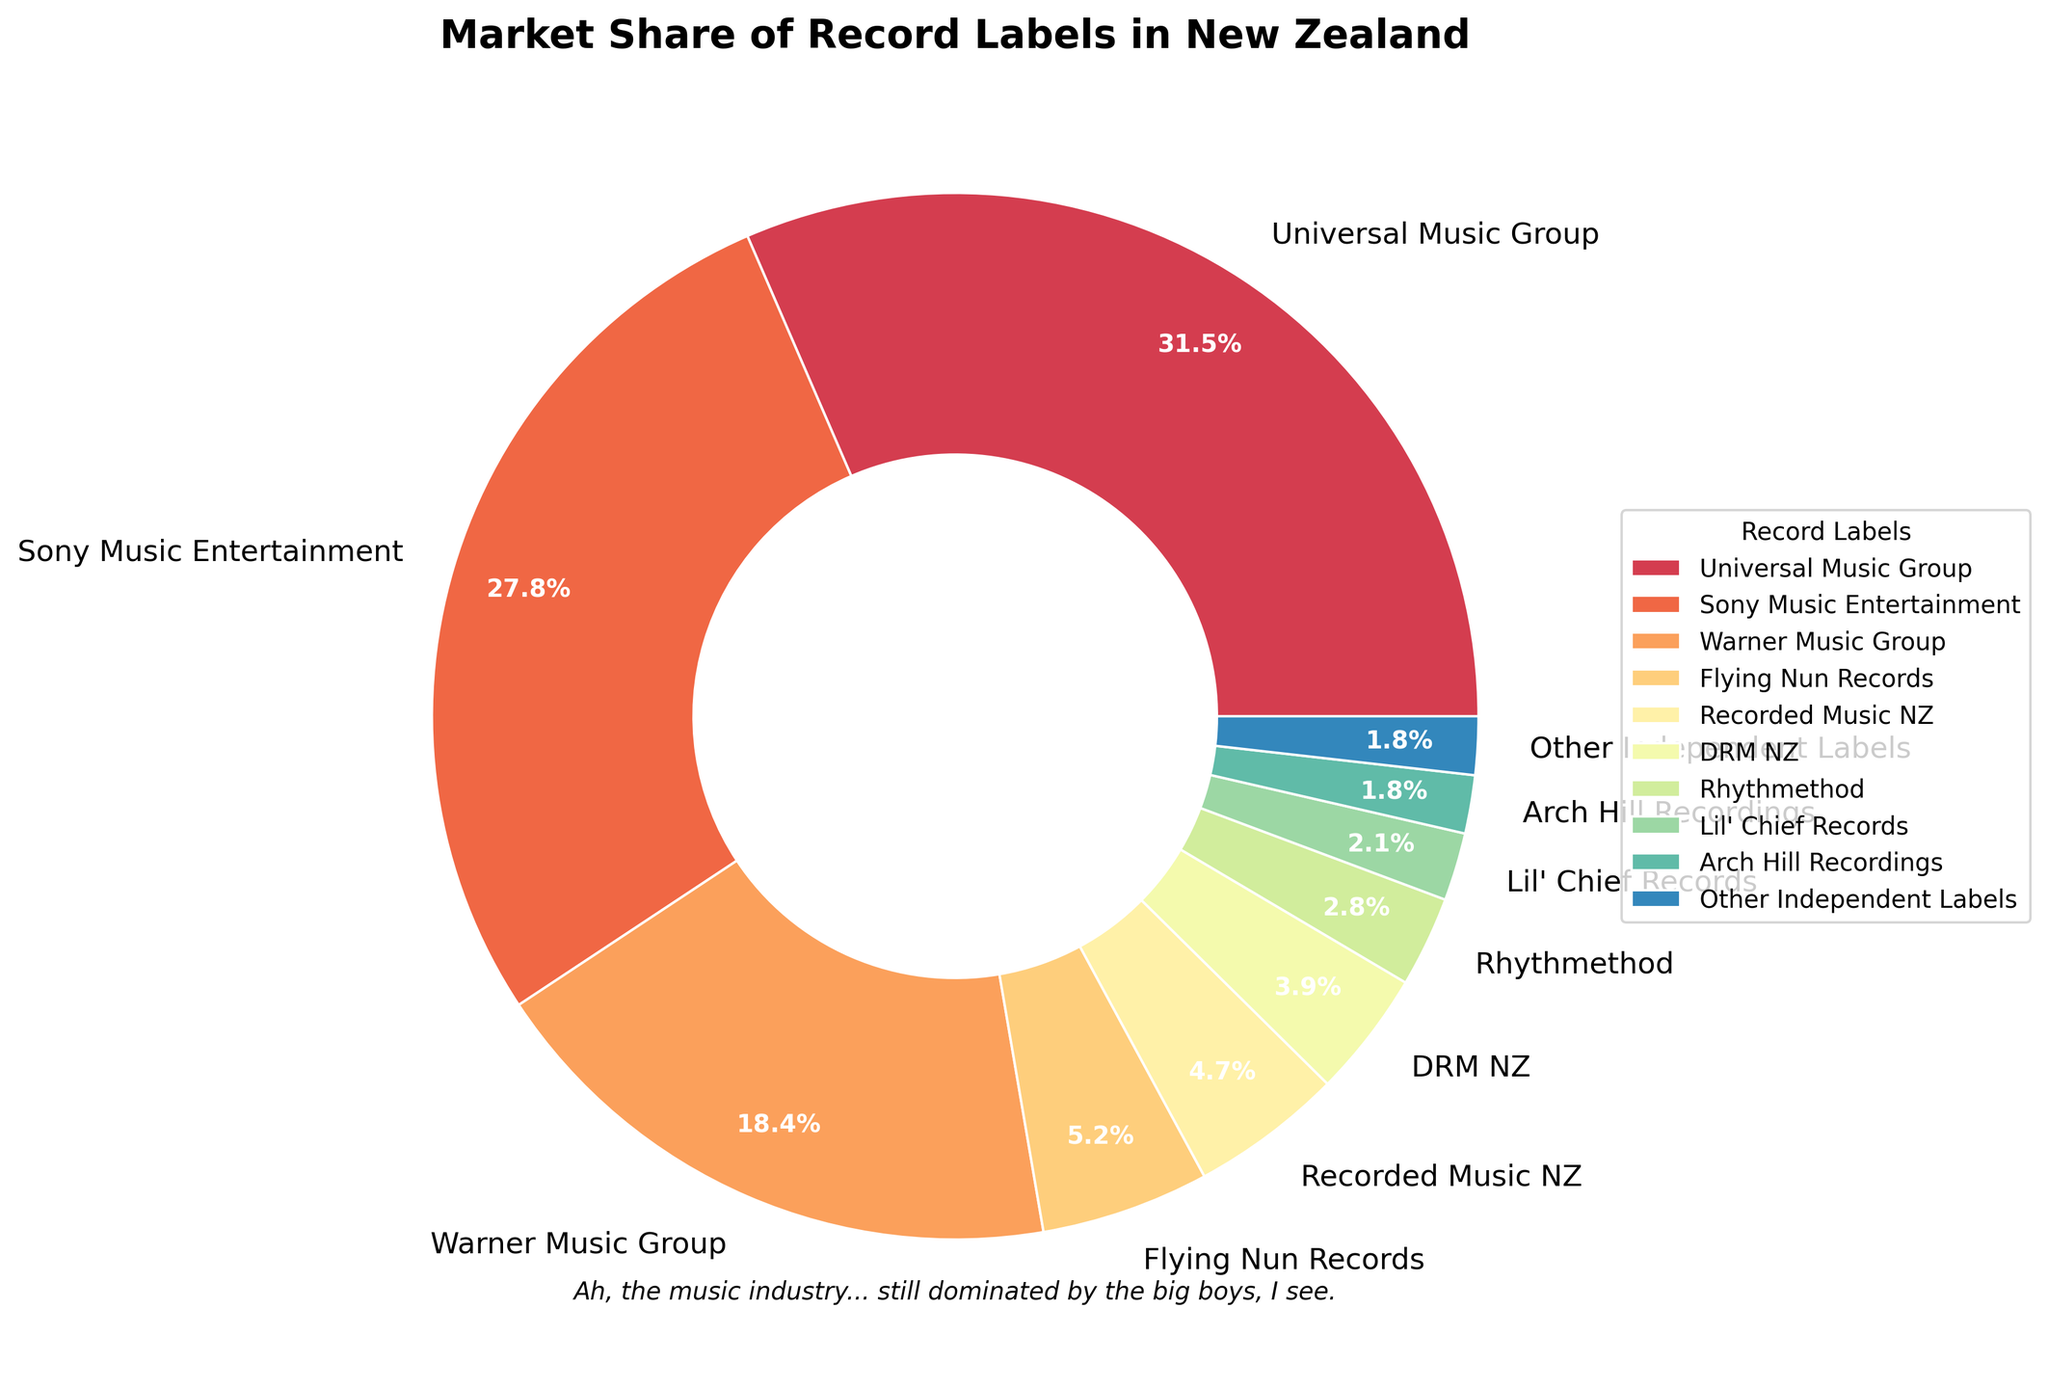Which record label has the highest market share? Looking at the pie chart, Universal Music Group has the largest slice of the pie, which represents 31.5% of the market share.
Answer: Universal Music Group How do the market shares of Sony Music Entertainment and Warner Music Group compare? According to the pie chart, Sony Music Entertainment has a 27.8% market share, while Warner Music Group has an 18.4% market share, so Sony Music Entertainment has a higher market share.
Answer: Sony Music Entertainment has a higher market share What is the combined market share of the top three record labels? Summing up the market shares of Universal Music Group (31.5%), Sony Music Entertainment (27.8%), and Warner Music Group (18.4%) gives a total of 31.5 + 27.8 + 18.4 = 77.7%.
Answer: 77.7% Which label has the smallest market share and how much is it? The pie chart shows that Arch Hill Recordings and Other Independent Labels both have the smallest market share at 1.8%.
Answer: Arch Hill Recordings and Other Independent Labels, 1.8% Calculate the average market share of all the independent labels combined (Flying Nun Records through Other Independent Labels). The independent labels listed are Flying Nun Records (5.2%), Recorded Music NZ (4.7%), DRM NZ (3.9%), Rhythmethod (2.8%), Lil' Chief Records (2.1%), Arch Hill Recordings (1.8%), and Other Independent Labels (1.8%). Summing these values gives 5.2 + 4.7 + 3.9 + 2.8 + 2.1 + 1.8 + 1.8 = 22.3%. There are 7 labels, so the average is 22.3 / 7 = 3.19%.
Answer: 3.19% By how much does Universal Music Group's market share exceed the combined market shares of Flying Nun Records and Recorded Music NZ? Universal Music Group has a 31.5% share. The combined shares of Flying Nun Records (5.2%) and Recorded Music NZ (4.7%) is 5.2 + 4.7 = 9.9%. Therefore, 31.5 - 9.9 = 21.6%.
Answer: 21.6% What visual feature helps in quickly identifying the label with the highest market share? Universal Music Group's slice is the largest and occupies the most space in the pie chart, making it quickly identifiable.
Answer: Largest slice How does the market share of Lil' Chief Records compare to DRM NZ? Lil' Chief Records has a 2.1% market share while DRM NZ has a 3.9% market share. DRM NZ has a higher market share.
Answer: DRM NZ has a higher market share What is the total market share represented by the independent labels listed in the chart? Adding the shares of all independent labels: Flying Nun Records (5.2%), Recorded Music NZ (4.7%), DRM NZ (3.9%), Rhythmethod (2.8%), Lil' Chief Records (2.1%), Arch Hill Recordings (1.8%), and Other Independent Labels (1.8%). The sum is 5.2 + 4.7 + 3.9 + 2.8 + 2.1 + 1.8 + 1.8 = 22.3%.
Answer: 22.3% 